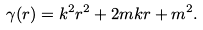Convert formula to latex. <formula><loc_0><loc_0><loc_500><loc_500>\gamma ( r ) = k ^ { 2 } r ^ { 2 } + 2 m k r + m ^ { 2 } .</formula> 